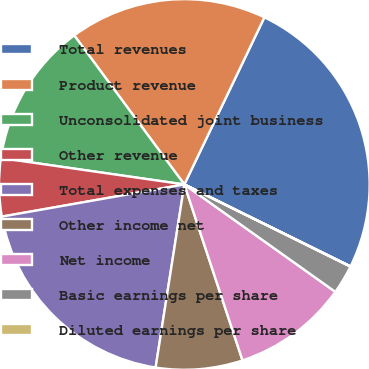Convert chart. <chart><loc_0><loc_0><loc_500><loc_500><pie_chart><fcel>Total revenues<fcel>Product revenue<fcel>Unconsolidated joint business<fcel>Other revenue<fcel>Total expenses and taxes<fcel>Other income net<fcel>Net income<fcel>Basic earnings per share<fcel>Diluted earnings per share<nl><fcel>25.18%<fcel>17.24%<fcel>12.6%<fcel>5.05%<fcel>19.75%<fcel>7.56%<fcel>10.08%<fcel>2.53%<fcel>0.02%<nl></chart> 